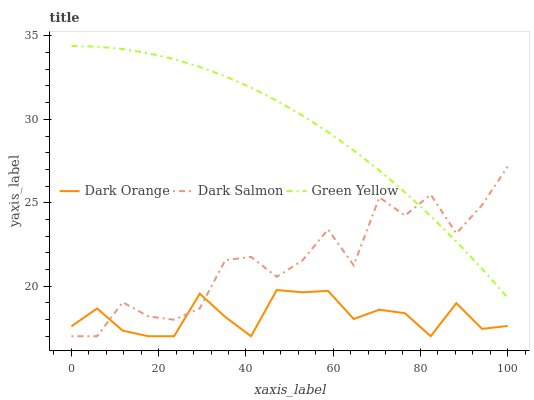Does Dark Orange have the minimum area under the curve?
Answer yes or no. Yes. Does Green Yellow have the maximum area under the curve?
Answer yes or no. Yes. Does Dark Salmon have the minimum area under the curve?
Answer yes or no. No. Does Dark Salmon have the maximum area under the curve?
Answer yes or no. No. Is Green Yellow the smoothest?
Answer yes or no. Yes. Is Dark Salmon the roughest?
Answer yes or no. Yes. Is Dark Salmon the smoothest?
Answer yes or no. No. Is Green Yellow the roughest?
Answer yes or no. No. Does Green Yellow have the lowest value?
Answer yes or no. No. Does Dark Salmon have the highest value?
Answer yes or no. No. Is Dark Orange less than Green Yellow?
Answer yes or no. Yes. Is Green Yellow greater than Dark Orange?
Answer yes or no. Yes. Does Dark Orange intersect Green Yellow?
Answer yes or no. No. 